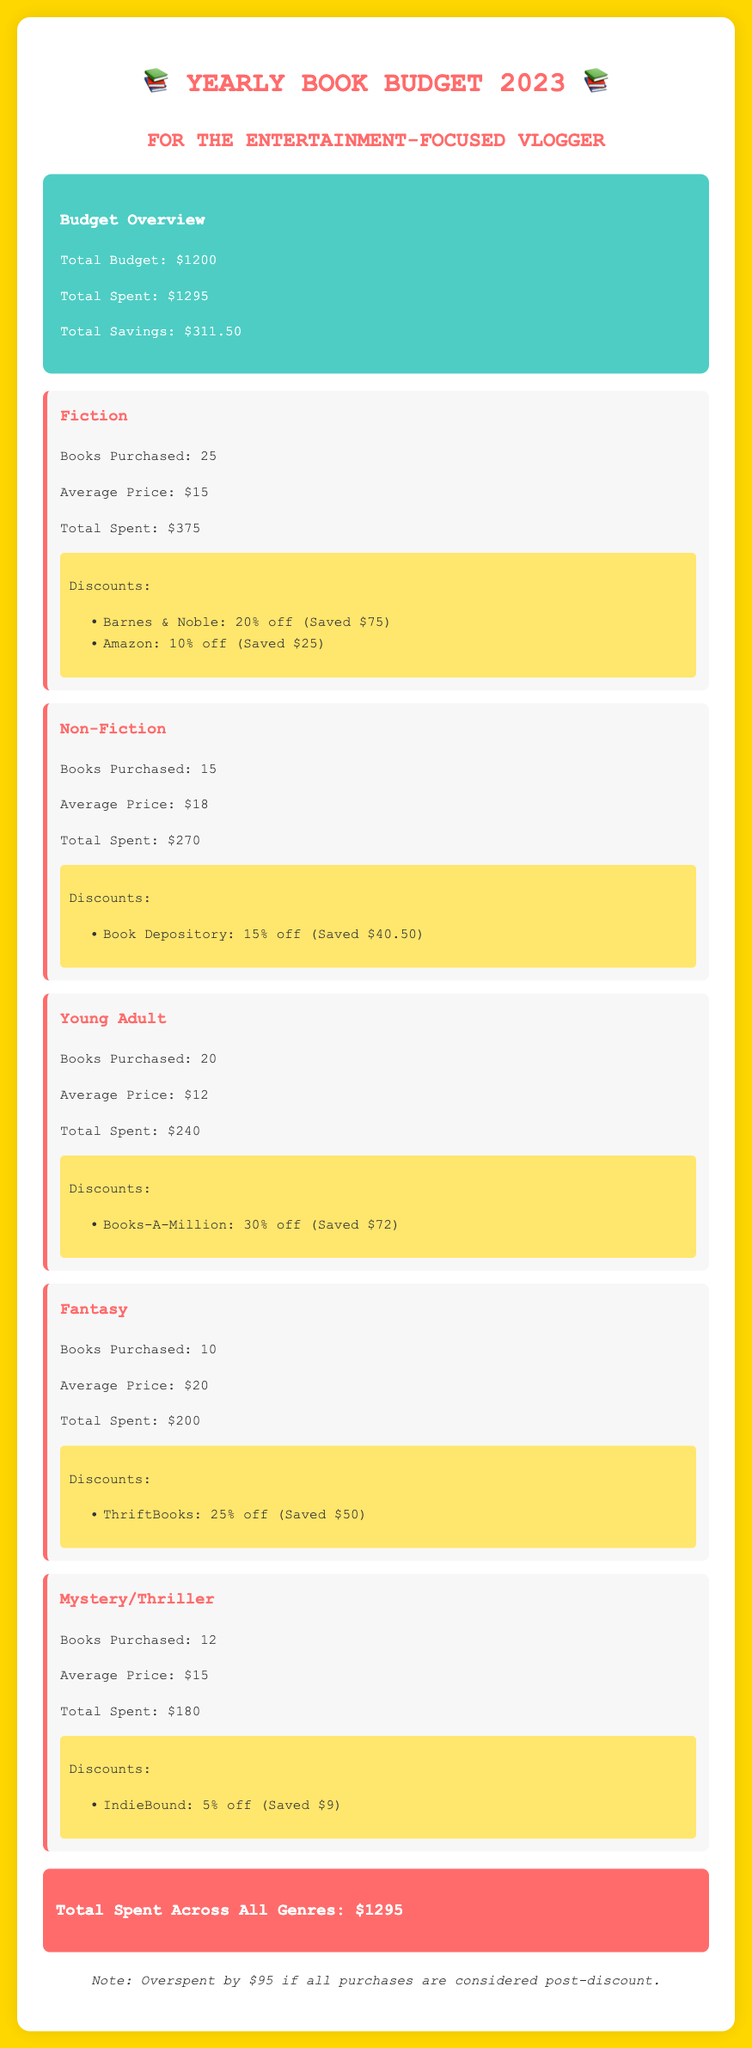What is the total budget? The total budget is listed in the budget overview section of the document.
Answer: $1200 How much was saved from the discounts on Fiction books? The savings from discounts on Fiction books include $75 from Barnes & Noble and $25 from Amazon.
Answer: $100 How many Fantasy books were purchased? The number of Fantasy books purchased is mentioned in their respective genre section.
Answer: 10 What was the average price of Non-Fiction books? The average price for Non-Fiction books is provided in the Non-Fiction genre section.
Answer: $18 What is the total amount spent on Young Adult books? The total amount spent on Young Adult books is directly stated in the genre section.
Answer: $240 How much was the total overspent after all purchases? The document includes a note about overspending based on post-discount calculations.
Answer: $95 Which genre had the highest number of books purchased? The number of books purchased for each genre is listed, with Fiction being mentioned as having the highest.
Answer: Fiction What is the total spent across all genres? The total spent across all genres is noted at the bottom of the document.
Answer: $1295 Which vendor offered the highest discount for Young Adult books? The discount for Young Adult books is specified in the genre section, with Books-A-Million offering the highest percentage off.
Answer: 30% 